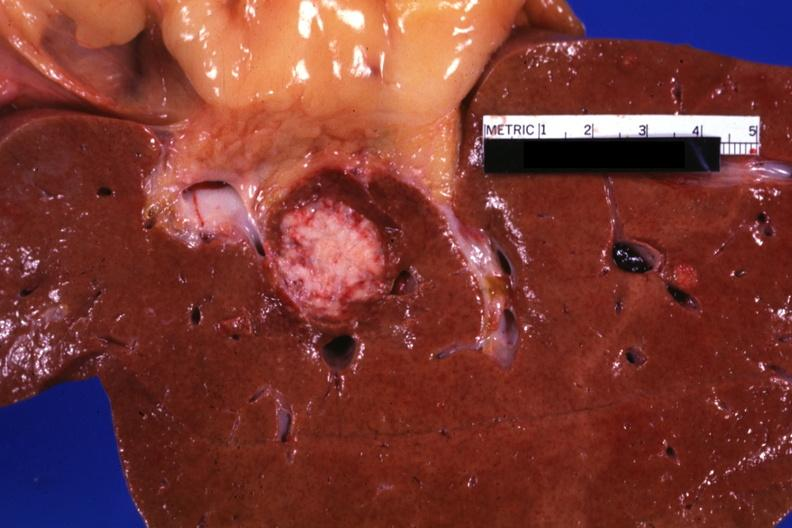s hepatobiliary present?
Answer the question using a single word or phrase. Yes 